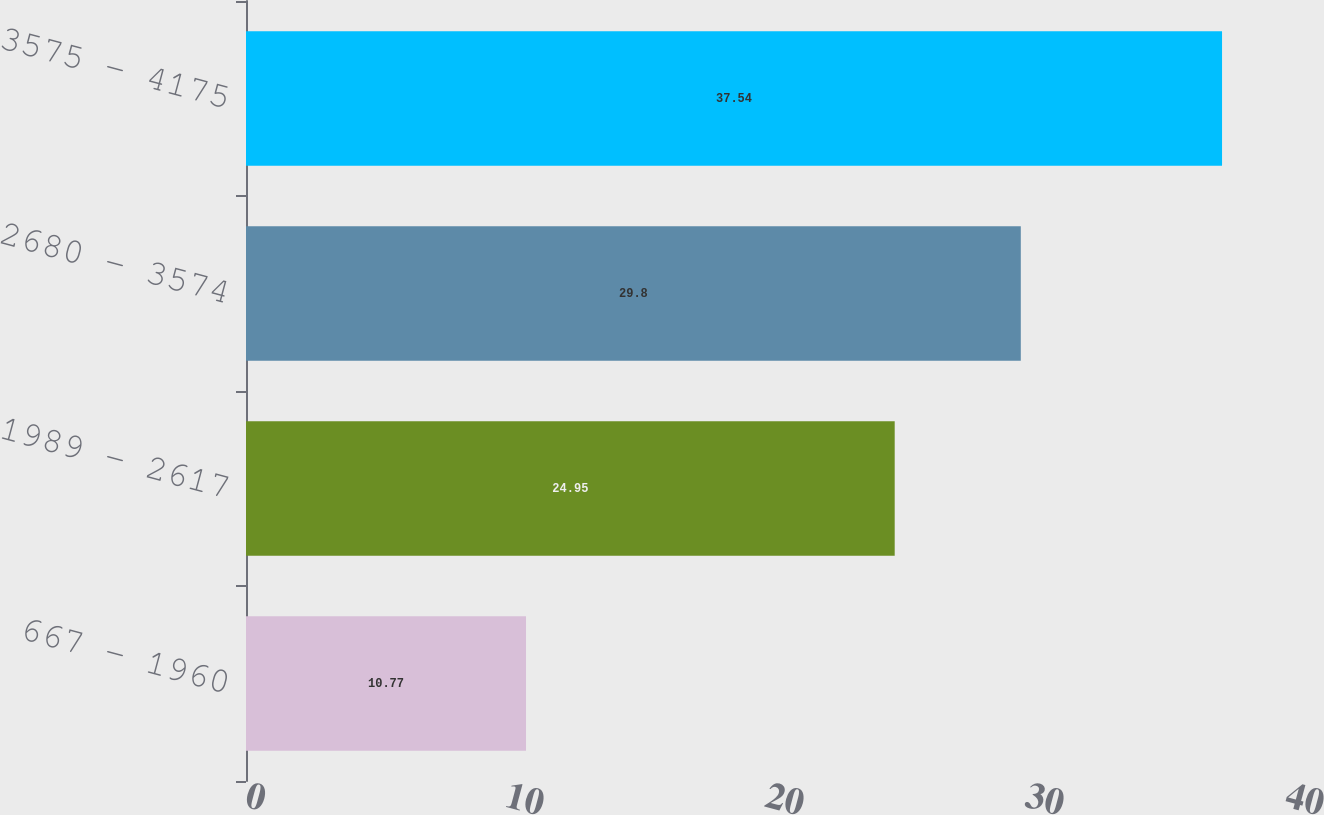Convert chart to OTSL. <chart><loc_0><loc_0><loc_500><loc_500><bar_chart><fcel>667 - 1960<fcel>1989 - 2617<fcel>2680 - 3574<fcel>3575 - 4175<nl><fcel>10.77<fcel>24.95<fcel>29.8<fcel>37.54<nl></chart> 